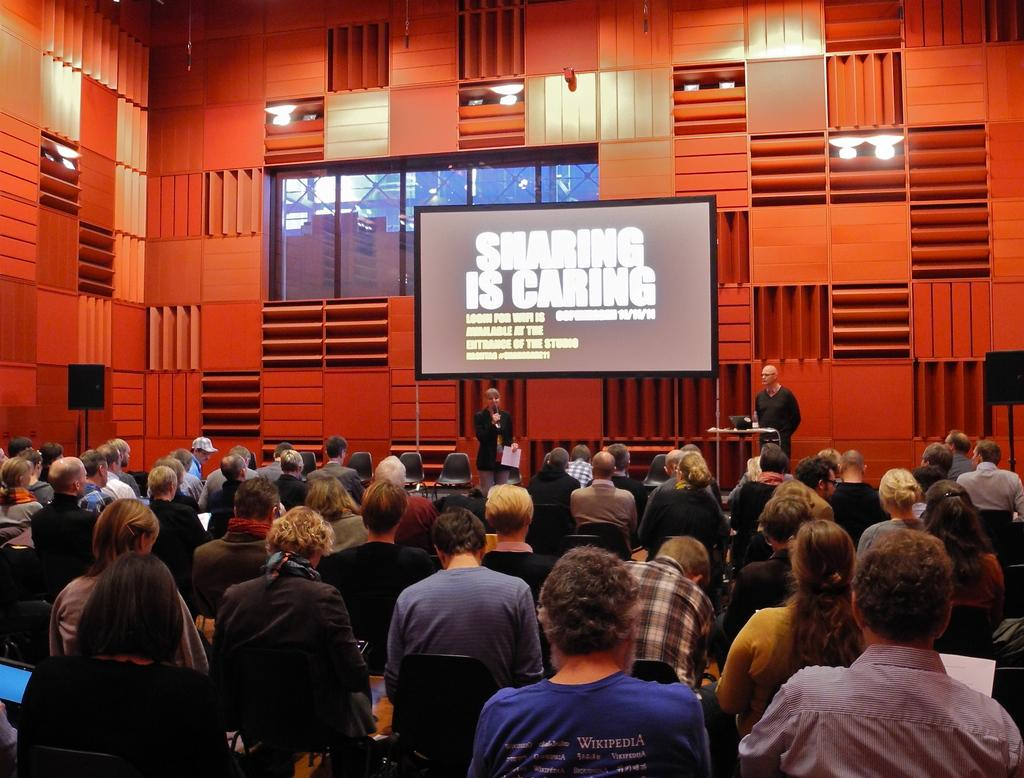What can be seen in the image involving multiple individuals? There is a group of people in the image. How can the dresses of the people in the group be described? The people are wearing different color dresses. Are there any specific individuals standing out in the group? Yes, there are two people standing in front of the group. What objects can be seen in the background of the image? There is a screen and a window in the image. What type of bun is being used to hold up the window in the image? There is no bun present in the image, and the window is not being held up by any bun. 